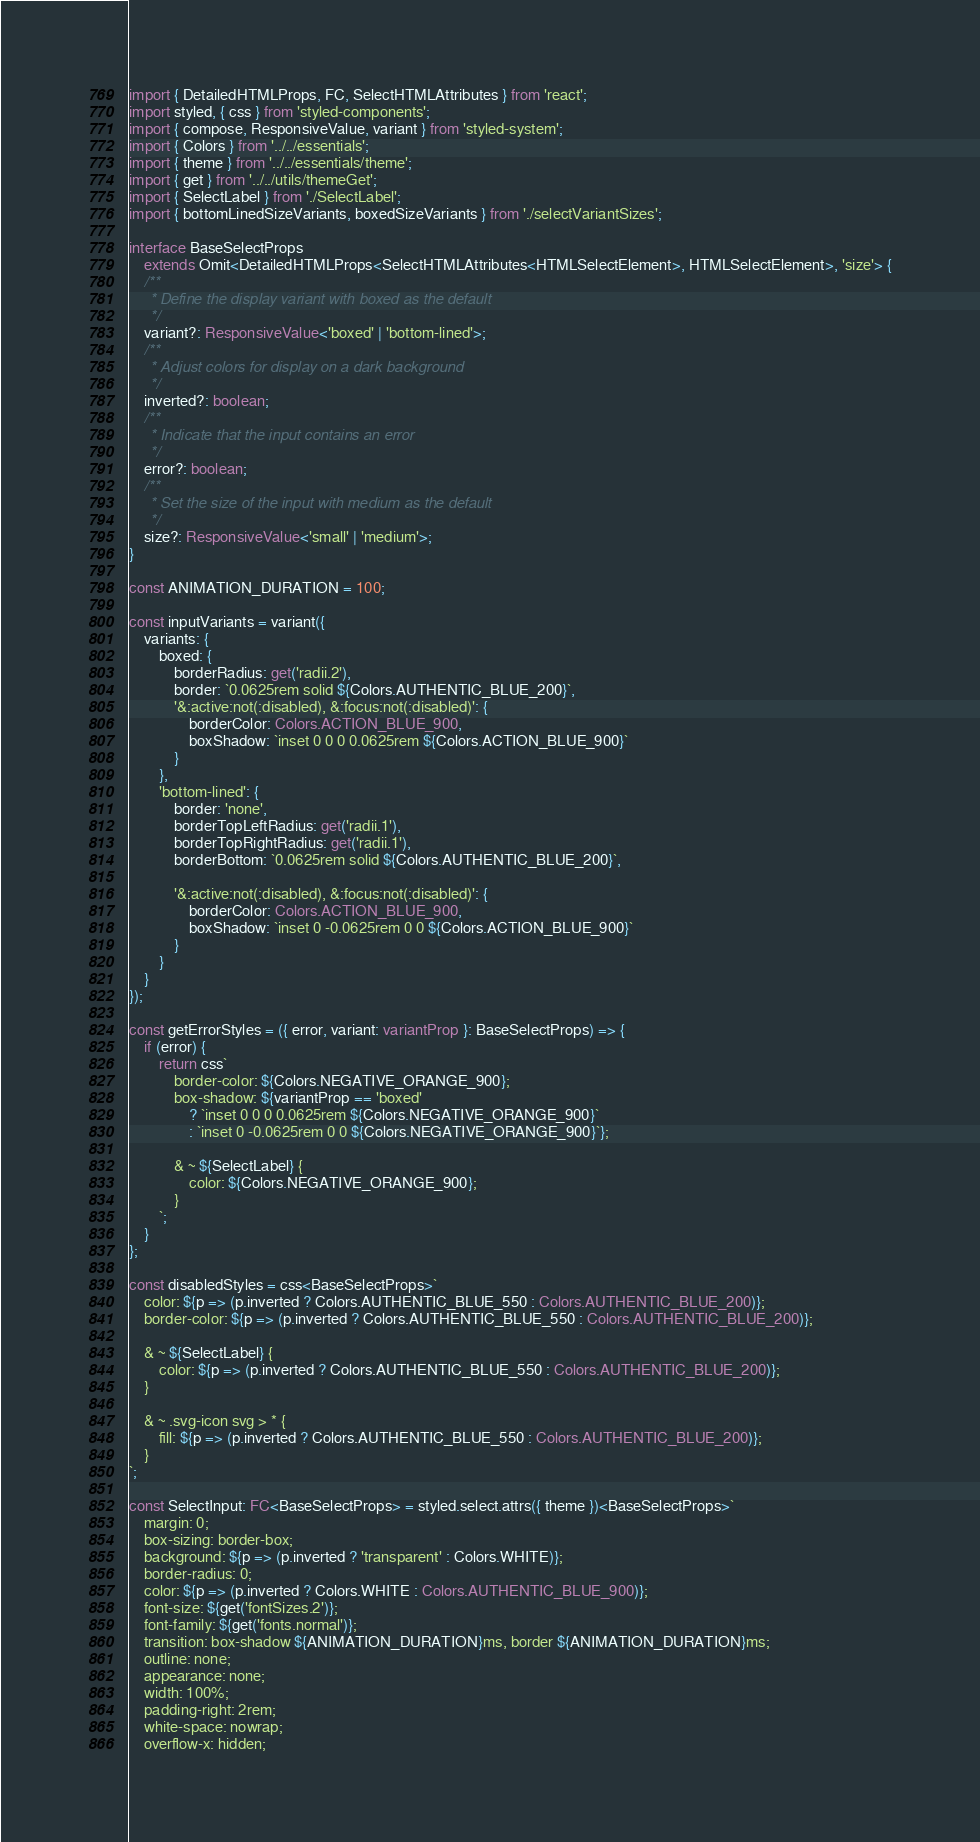Convert code to text. <code><loc_0><loc_0><loc_500><loc_500><_TypeScript_>import { DetailedHTMLProps, FC, SelectHTMLAttributes } from 'react';
import styled, { css } from 'styled-components';
import { compose, ResponsiveValue, variant } from 'styled-system';
import { Colors } from '../../essentials';
import { theme } from '../../essentials/theme';
import { get } from '../../utils/themeGet';
import { SelectLabel } from './SelectLabel';
import { bottomLinedSizeVariants, boxedSizeVariants } from './selectVariantSizes';

interface BaseSelectProps
    extends Omit<DetailedHTMLProps<SelectHTMLAttributes<HTMLSelectElement>, HTMLSelectElement>, 'size'> {
    /**
     * Define the display variant with boxed as the default
     */
    variant?: ResponsiveValue<'boxed' | 'bottom-lined'>;
    /**
     * Adjust colors for display on a dark background
     */
    inverted?: boolean;
    /**
     * Indicate that the input contains an error
     */
    error?: boolean;
    /**
     * Set the size of the input with medium as the default
     */
    size?: ResponsiveValue<'small' | 'medium'>;
}

const ANIMATION_DURATION = 100;

const inputVariants = variant({
    variants: {
        boxed: {
            borderRadius: get('radii.2'),
            border: `0.0625rem solid ${Colors.AUTHENTIC_BLUE_200}`,
            '&:active:not(:disabled), &:focus:not(:disabled)': {
                borderColor: Colors.ACTION_BLUE_900,
                boxShadow: `inset 0 0 0 0.0625rem ${Colors.ACTION_BLUE_900}`
            }
        },
        'bottom-lined': {
            border: 'none',
            borderTopLeftRadius: get('radii.1'),
            borderTopRightRadius: get('radii.1'),
            borderBottom: `0.0625rem solid ${Colors.AUTHENTIC_BLUE_200}`,

            '&:active:not(:disabled), &:focus:not(:disabled)': {
                borderColor: Colors.ACTION_BLUE_900,
                boxShadow: `inset 0 -0.0625rem 0 0 ${Colors.ACTION_BLUE_900}`
            }
        }
    }
});

const getErrorStyles = ({ error, variant: variantProp }: BaseSelectProps) => {
    if (error) {
        return css`
            border-color: ${Colors.NEGATIVE_ORANGE_900};
            box-shadow: ${variantProp == 'boxed'
                ? `inset 0 0 0 0.0625rem ${Colors.NEGATIVE_ORANGE_900}`
                : `inset 0 -0.0625rem 0 0 ${Colors.NEGATIVE_ORANGE_900}`};

            & ~ ${SelectLabel} {
                color: ${Colors.NEGATIVE_ORANGE_900};
            }
        `;
    }
};

const disabledStyles = css<BaseSelectProps>`
    color: ${p => (p.inverted ? Colors.AUTHENTIC_BLUE_550 : Colors.AUTHENTIC_BLUE_200)};
    border-color: ${p => (p.inverted ? Colors.AUTHENTIC_BLUE_550 : Colors.AUTHENTIC_BLUE_200)};

    & ~ ${SelectLabel} {
        color: ${p => (p.inverted ? Colors.AUTHENTIC_BLUE_550 : Colors.AUTHENTIC_BLUE_200)};
    }

    & ~ .svg-icon svg > * {
        fill: ${p => (p.inverted ? Colors.AUTHENTIC_BLUE_550 : Colors.AUTHENTIC_BLUE_200)};
    }
`;

const SelectInput: FC<BaseSelectProps> = styled.select.attrs({ theme })<BaseSelectProps>`
    margin: 0;
    box-sizing: border-box;
    background: ${p => (p.inverted ? 'transparent' : Colors.WHITE)};
    border-radius: 0;
    color: ${p => (p.inverted ? Colors.WHITE : Colors.AUTHENTIC_BLUE_900)};
    font-size: ${get('fontSizes.2')};
    font-family: ${get('fonts.normal')};
    transition: box-shadow ${ANIMATION_DURATION}ms, border ${ANIMATION_DURATION}ms;
    outline: none;
    appearance: none;
    width: 100%;
    padding-right: 2rem;
    white-space: nowrap;
    overflow-x: hidden;</code> 